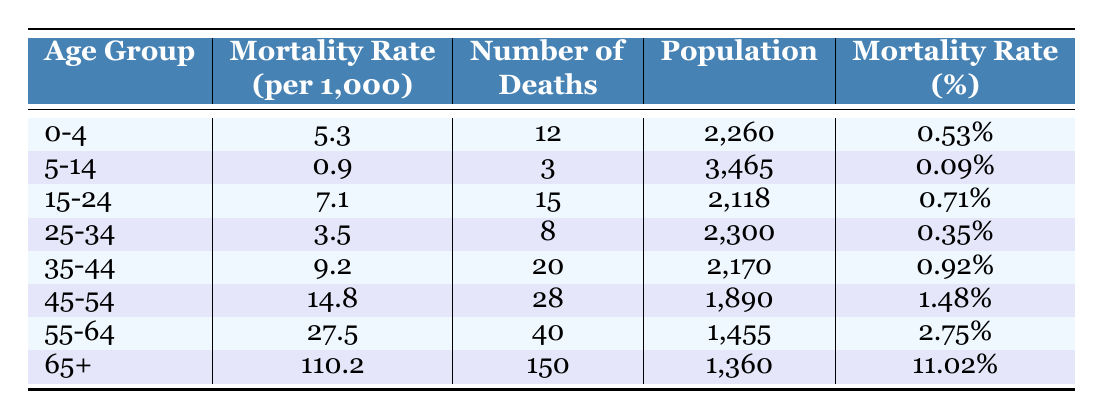What is the mortality rate for the age group 0-4? According to the table, the mortality rate for the age group 0-4 is 5.3 deaths per 1,000 individuals.
Answer: 5.3 How many deaths occurred in the age group 55-64? The table shows that there were 40 deaths in the age group 55-64.
Answer: 40 Which age group has the highest mortality rate? By examining the mortality rates listed in the table, the age group 65+ has the highest mortality rate at 110.2 deaths per 1,000.
Answer: 65+ What is the total number of deaths across all age groups? To find the total number of deaths, sum the number of deaths in each age group: 12 + 3 + 15 + 8 + 20 + 28 + 40 + 150 = 276.
Answer: 276 Is the mortality rate for the age group 25-34 higher than that for 15-24? The mortality rate for age group 25-34 is 3.5, which is less than the mortality rate for age group 15-24, which is 7.1. Thus, the statement is false.
Answer: No What is the percentage of deaths for the age group 45-54? The table lists the number of deaths for the age group 45-54 as 28, and the population as 1,890. To find the percentage, calculate (28/1890) * 100 = 1.48%.
Answer: 1.48% Which age group has a mortality rate that is more than double that of the 5-14 age group? The mortality rate for the age group 5-14 is 0.9. The only group with a higher mortality rate than double this is age group 55-64, which has a mortality rate of 27.5.
Answer: 55-64 If we average the mortality rates of all age groups, what is the result? Calculate the average by summing all mortality rates: (5.3 + 0.9 + 7.1 + 3.5 + 9.2 + 14.8 + 27.5 + 110.2) = 178.5. Then, divide by the number of age groups (8): 178.5 / 8 = 22.31.
Answer: 22.31 How does the number of deaths in the age group 65+ compare to the total deaths under 15? There are 150 deaths in the age group 65+, while deaths under 15 (in age groups 0-4 and 5-14) total 12 + 3 = 15. Since 150 is much greater than 15, we conclude that the age group 65+ has significantly more deaths.
Answer: Greater 